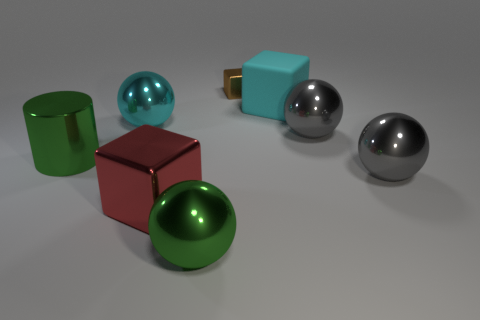Is there any other thing that has the same material as the big cyan block?
Offer a very short reply. No. What is the shape of the thing that is behind the large matte cube that is on the right side of the small thing that is on the right side of the large cyan metallic object?
Offer a very short reply. Cube. How many other objects are there of the same shape as the large red thing?
Give a very brief answer. 2. How many metallic objects are gray balls or big gray cubes?
Offer a very short reply. 2. What material is the big gray sphere in front of the big green metal cylinder in front of the small brown metal object?
Your response must be concise. Metal. Are there more cyan metal balls that are behind the big red shiny cube than small cyan balls?
Your answer should be very brief. Yes. Are there any brown blocks that have the same material as the large cylinder?
Offer a very short reply. Yes. There is a cyan object that is to the right of the big green ball; is it the same shape as the tiny brown thing?
Make the answer very short. Yes. There is a ball that is left of the big green metal object on the right side of the shiny cylinder; what number of cylinders are behind it?
Your response must be concise. 0. Are there fewer large shiny spheres left of the big cyan rubber block than things that are right of the brown metallic block?
Keep it short and to the point. Yes. 